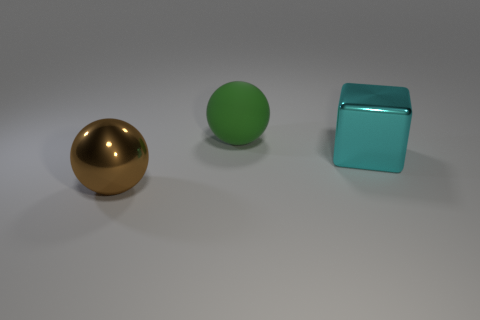Is there anything else that has the same shape as the cyan object?
Offer a very short reply. No. Do the sphere that is in front of the green sphere and the object that is right of the large green matte thing have the same material?
Ensure brevity in your answer.  Yes. There is a thing that is to the left of the cyan thing and in front of the large green rubber thing; what shape is it?
Provide a succinct answer. Sphere. What color is the object that is to the left of the cube and in front of the green object?
Offer a very short reply. Brown. Is the number of objects behind the big brown ball greater than the number of metallic blocks that are on the left side of the big cyan block?
Your answer should be very brief. Yes. What is the color of the metallic thing behind the brown metallic ball?
Keep it short and to the point. Cyan. There is a large thing that is in front of the large cyan metal cube; is its shape the same as the large green object on the right side of the brown shiny thing?
Offer a terse response. Yes. Is there a cyan metallic thing that has the same size as the brown sphere?
Offer a terse response. Yes. There is a big ball to the right of the brown shiny sphere; what is it made of?
Your response must be concise. Rubber. Are the sphere in front of the shiny cube and the cyan object made of the same material?
Your answer should be compact. Yes. 